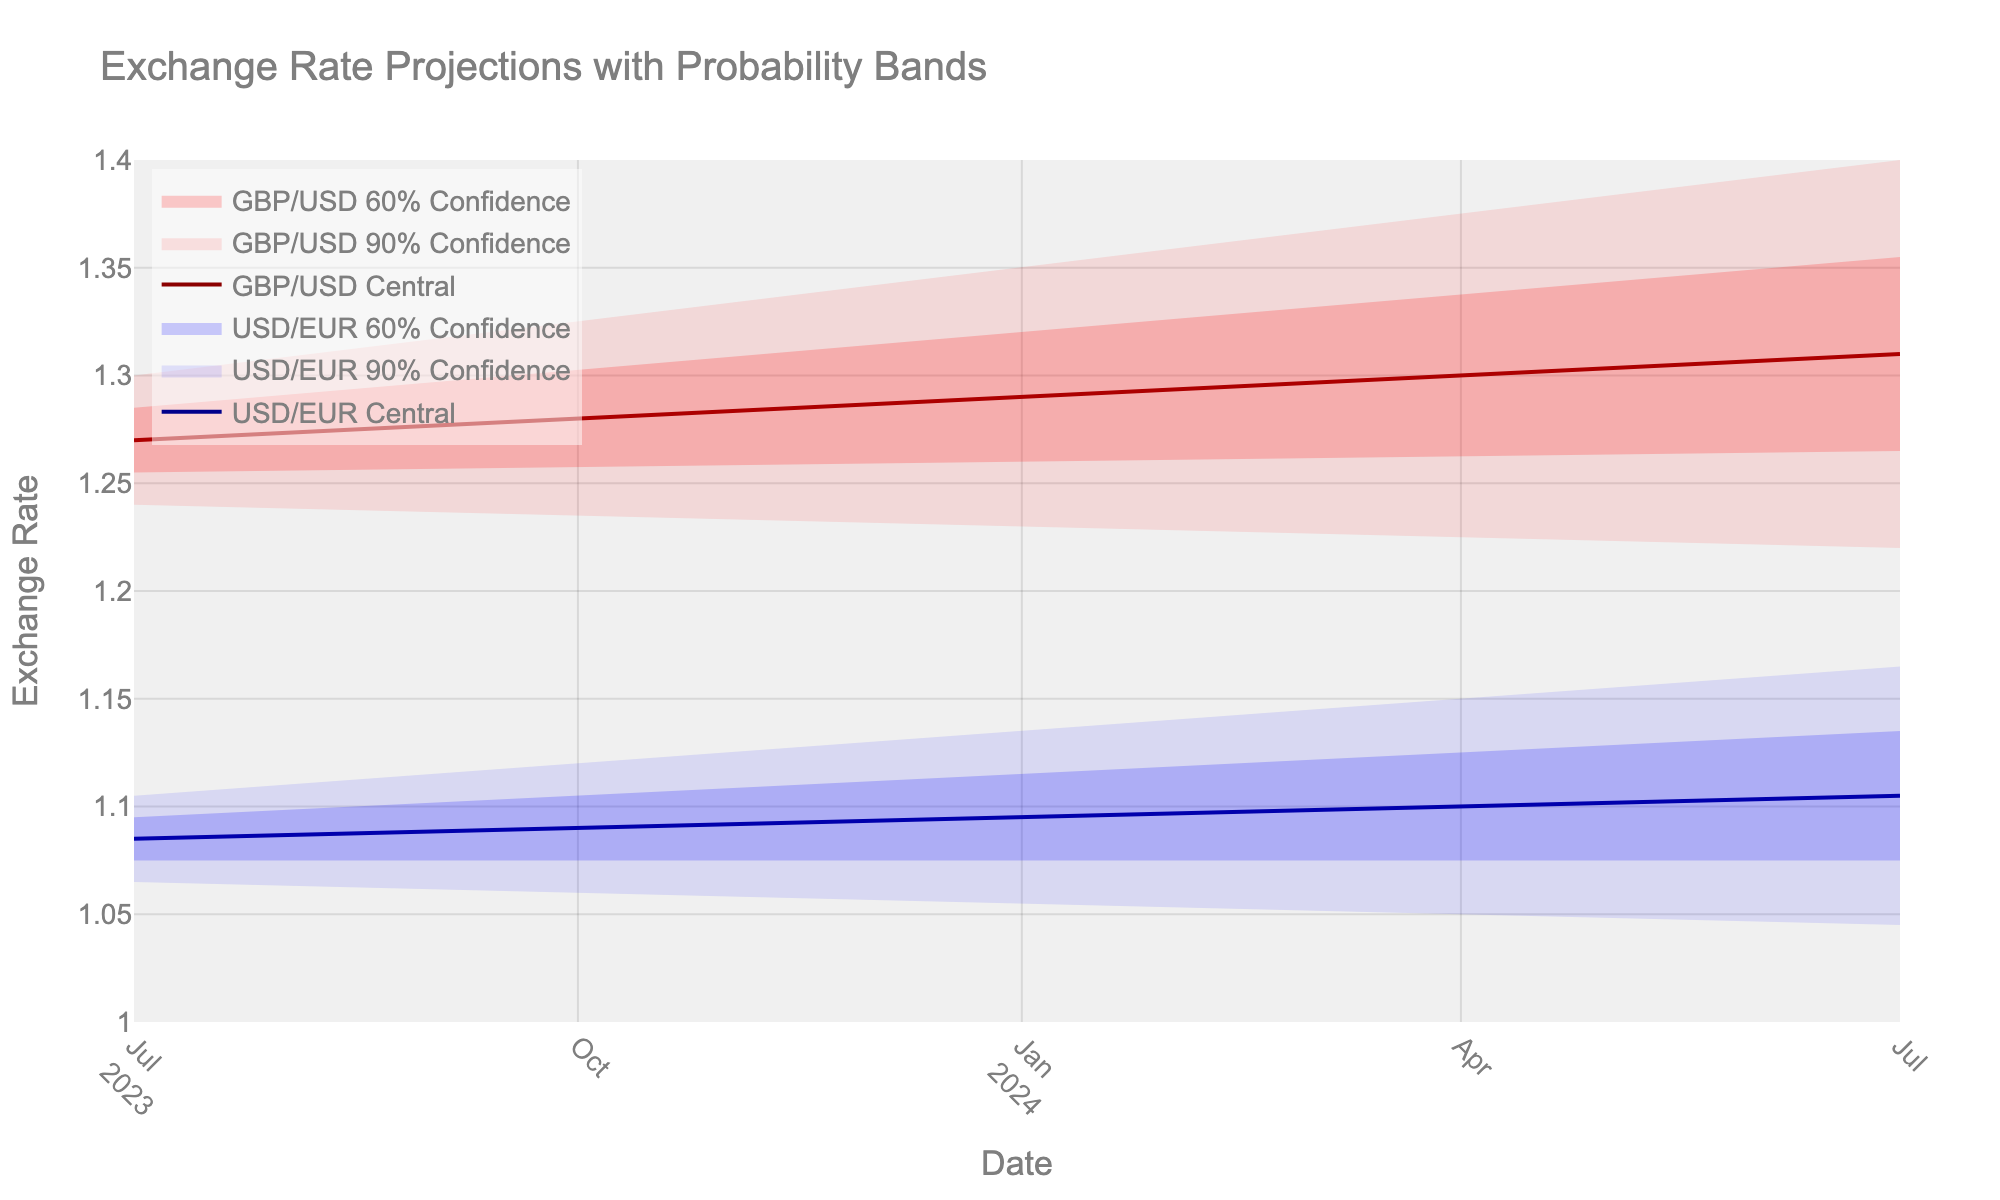What is the title of the plot? The title of the plot is usually prominently displayed at the top of the figure. In this case, the title is "Exchange Rate Projections with Probability Bands".
Answer: Exchange Rate Projections with Probability Bands What is the USD/EUR central exchange rate forecast for January 2024? The central exchange rate forecast for January 2024 is represented by the dark blue line in the plot. Locating January 2024 on the x-axis and tracing it up to the dark blue line gives the central forecast value.
Answer: 1.0950 Between which dates does the GBP/USD 90% confidence interval increase the most? The 90% confidence interval is represented by the light red shaded region. By comparing the width of this interval between different dates, one can determine where it increases the most significantly. The interval appears to widen most notably from October 2023 to April 2024.
Answer: October 2023 to April 2024 How does the USD/EUR projection for July 2024 compare to that of July 2023? To compare these two dates, we look at the central projections for both July 2023 and July 2024 on the dark blue line and compare the values. July 2024's central projection (1.1050) is higher than that of July 2023 (1.0850).
Answer: July 2024 is higher What is the general trend for GBP/USD central estimates from July 2023 to July 2024? By examining the dark red line representing GBP/USD central estimates, we can see the overall direction of the trend. The estimates steadily rise from 1.2700 in July 2023 to 1.3100 in July 2024.
Answer: Increasing What is the range of the USD/EUR 60% confidence interval in April 2024? To find the range, subtract the lower bound of the 60% confidence interval from the upper bound for April 2024. The lower bound is 1.0750, and the upper bound is 1.1250.
Answer: 0.0500 How does the width of the GBP/USD 60% confidence interval in January 2024 compare to that of April 2024? The width of the 60% confidence interval is found by subtracting the lower bound from the upper bound for both months. For January 2024: 1.3200 - 1.2600 = 0.0600. For April 2024: 1.3375 - 1.2625 = 0.0750. By comparing these values, April 2024 has a wider interval.
Answer: April 2024 is wider What is the expected range for GBP/USD in July 2024 within the 90% confidence interval? The 90% confidence interval is indicated by the light red shaded area. For July 2024, the lower bound is 1.2200 and the upper bound is 1.4000. This gives a range of [1.2200, 1.4000].
Answer: [1.2200, 1.4000] At which date do the central forecasts for USD/EUR and GBP/USD have the smallest differential? To find the smallest differential, calculate the difference between the central forecasts for each date and find the minimum. The smallest differential is at July 2023:
Answer: 0.1850 